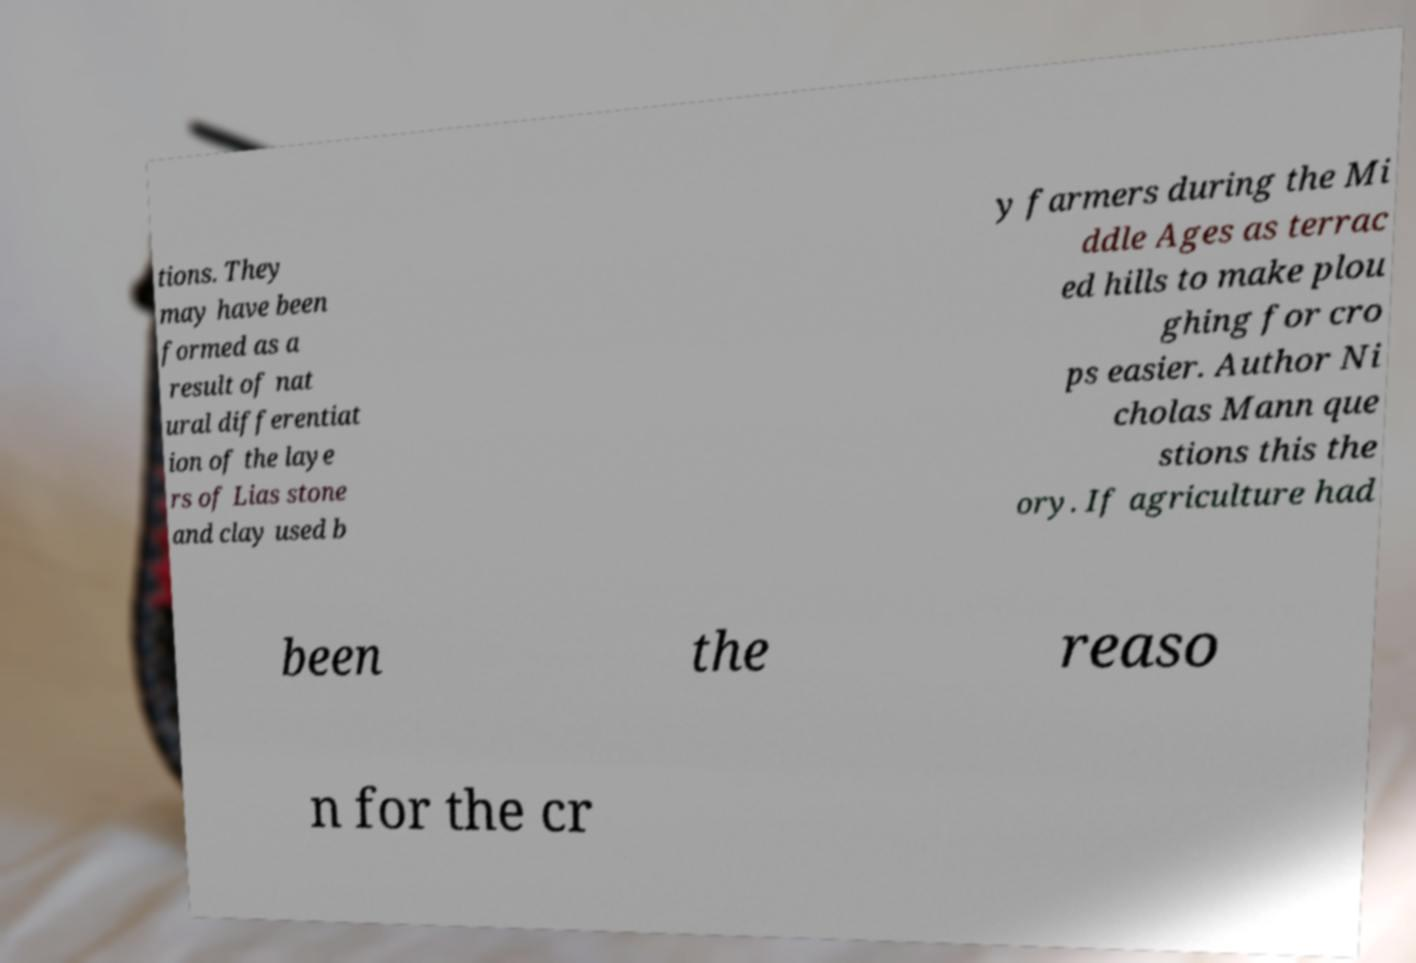Can you read and provide the text displayed in the image?This photo seems to have some interesting text. Can you extract and type it out for me? tions. They may have been formed as a result of nat ural differentiat ion of the laye rs of Lias stone and clay used b y farmers during the Mi ddle Ages as terrac ed hills to make plou ghing for cro ps easier. Author Ni cholas Mann que stions this the ory. If agriculture had been the reaso n for the cr 